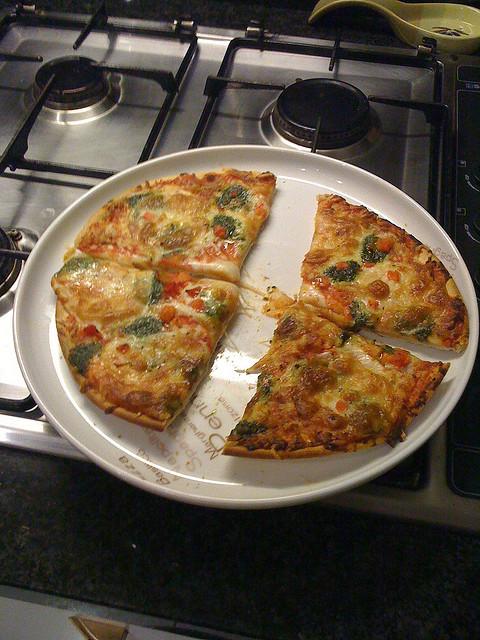Does this type of division have the same name as a coin?
Quick response, please. Yes. How many slices are there on each pizza?
Give a very brief answer. 4. Has the pizza been baked?
Give a very brief answer. Yes. What fuels this stove?
Write a very short answer. Gas. 